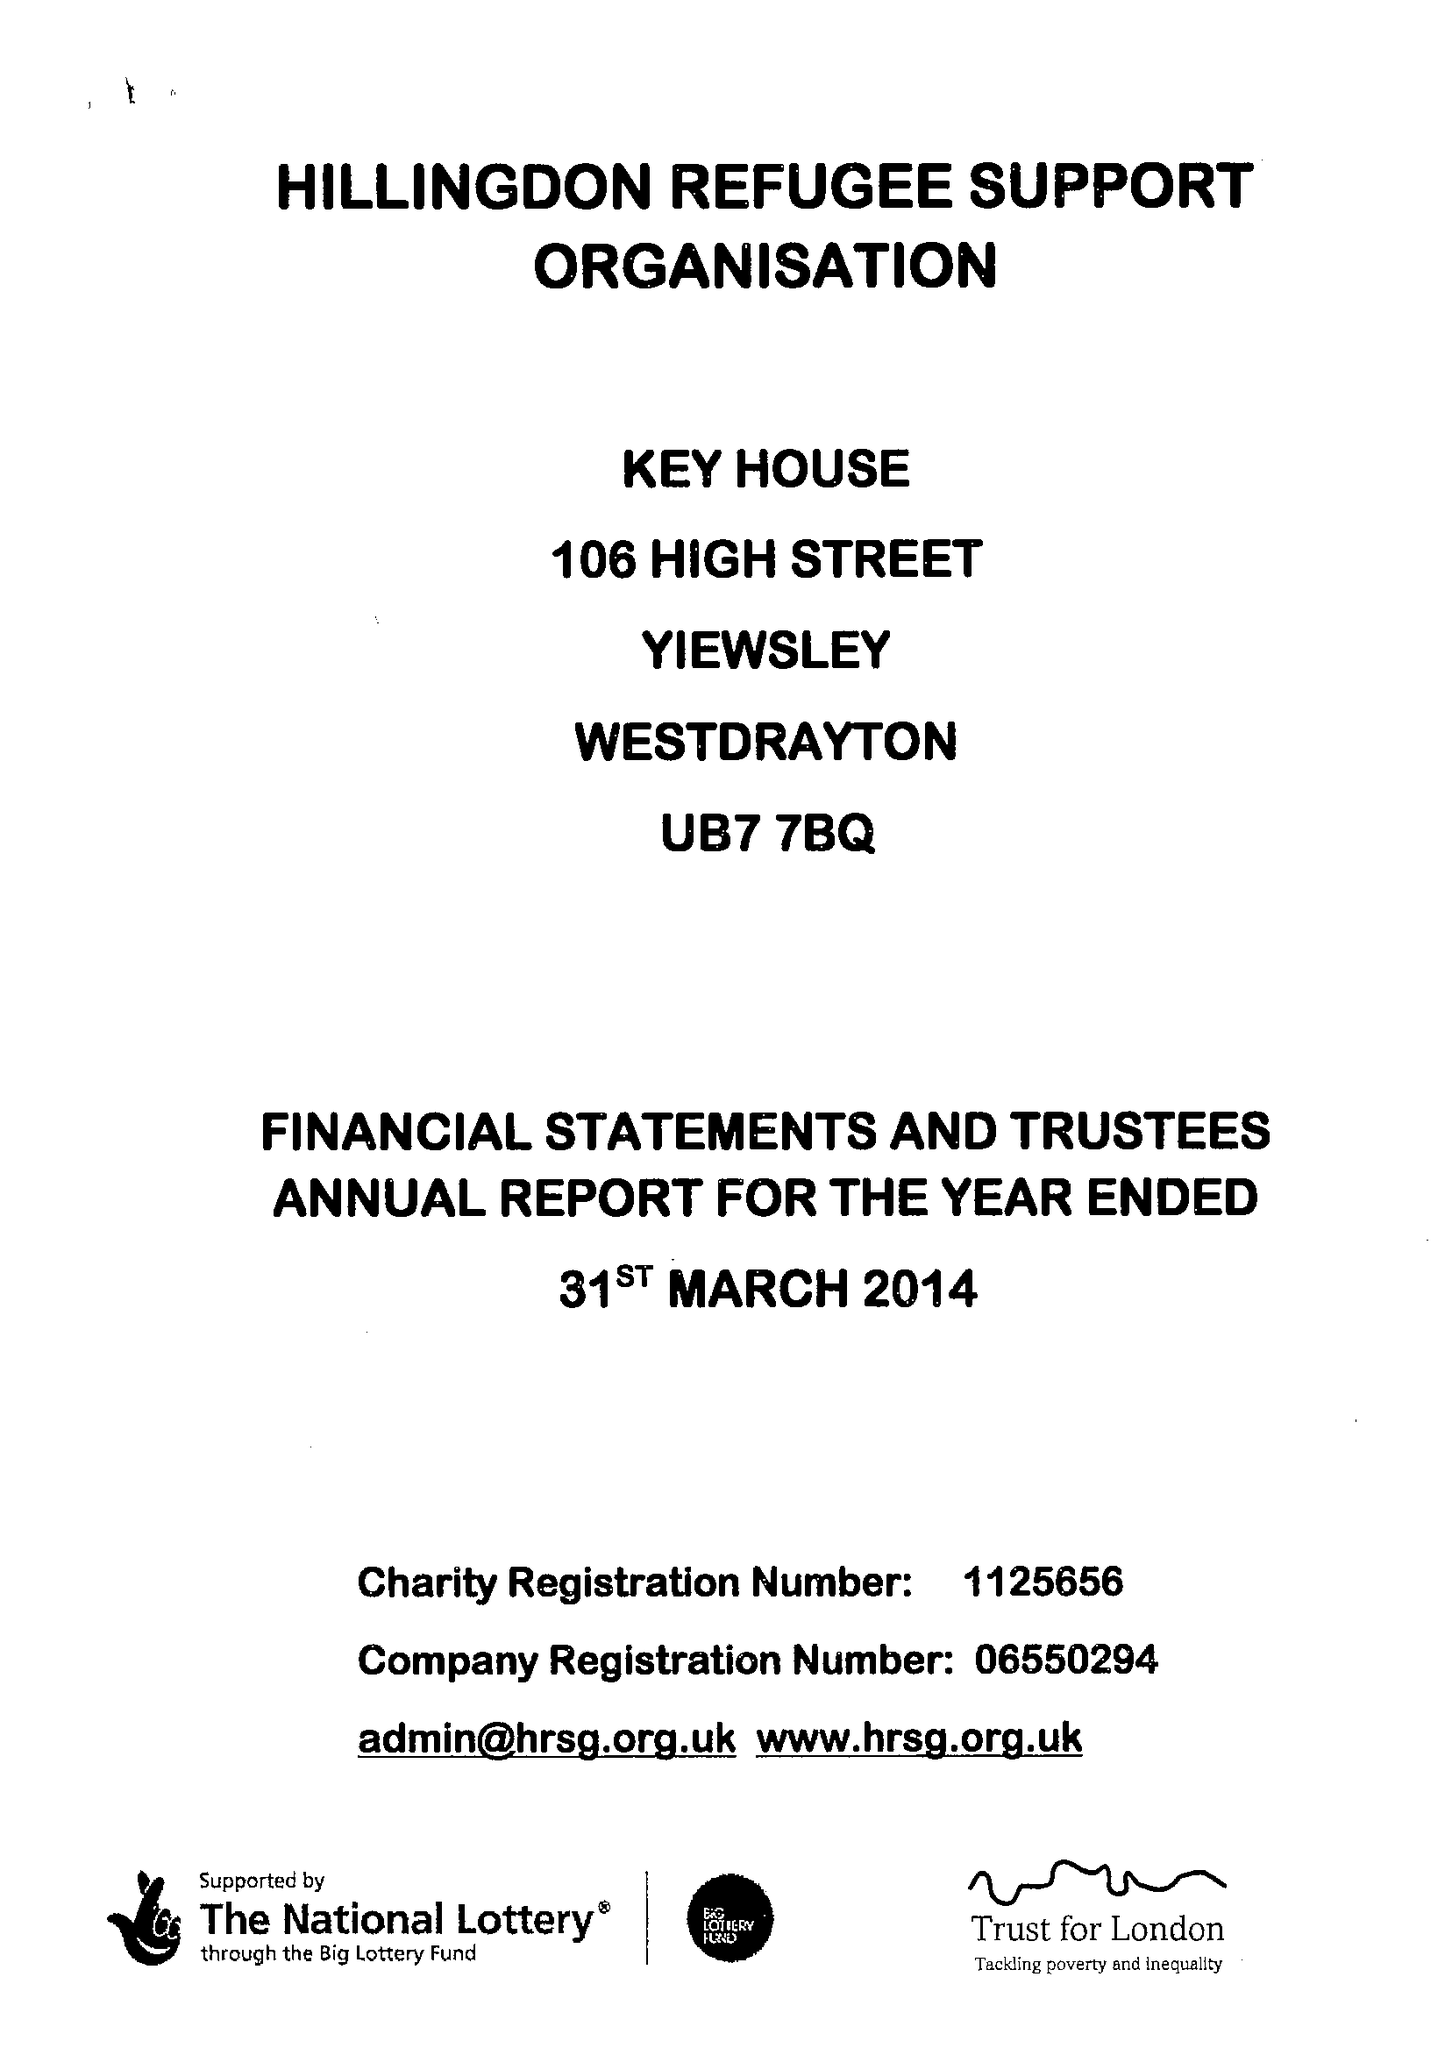What is the value for the spending_annually_in_british_pounds?
Answer the question using a single word or phrase. 103875.00 